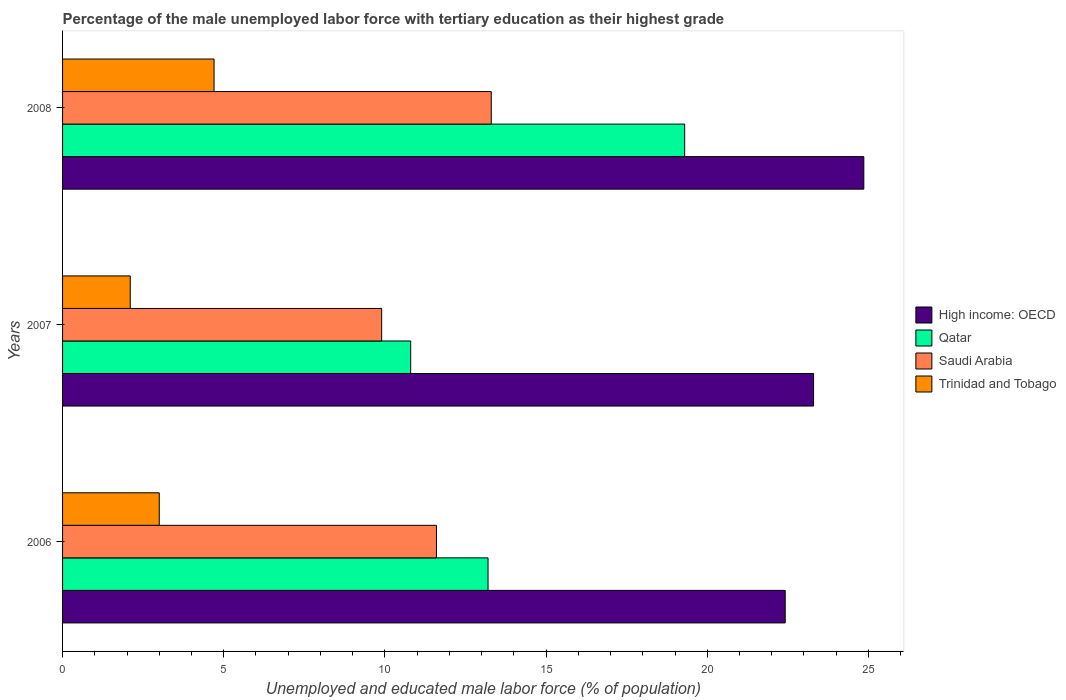How many different coloured bars are there?
Ensure brevity in your answer.  4. Are the number of bars on each tick of the Y-axis equal?
Give a very brief answer. Yes. What is the label of the 2nd group of bars from the top?
Give a very brief answer. 2007. What is the percentage of the unemployed male labor force with tertiary education in Qatar in 2006?
Make the answer very short. 13.2. Across all years, what is the maximum percentage of the unemployed male labor force with tertiary education in High income: OECD?
Provide a succinct answer. 24.86. Across all years, what is the minimum percentage of the unemployed male labor force with tertiary education in High income: OECD?
Provide a succinct answer. 22.42. In which year was the percentage of the unemployed male labor force with tertiary education in Trinidad and Tobago minimum?
Offer a terse response. 2007. What is the total percentage of the unemployed male labor force with tertiary education in High income: OECD in the graph?
Your answer should be very brief. 70.58. What is the difference between the percentage of the unemployed male labor force with tertiary education in High income: OECD in 2006 and that in 2007?
Your response must be concise. -0.88. What is the difference between the percentage of the unemployed male labor force with tertiary education in Qatar in 2008 and the percentage of the unemployed male labor force with tertiary education in Trinidad and Tobago in 2007?
Keep it short and to the point. 17.2. What is the average percentage of the unemployed male labor force with tertiary education in High income: OECD per year?
Your answer should be very brief. 23.53. In the year 2006, what is the difference between the percentage of the unemployed male labor force with tertiary education in High income: OECD and percentage of the unemployed male labor force with tertiary education in Qatar?
Make the answer very short. 9.22. What is the ratio of the percentage of the unemployed male labor force with tertiary education in Qatar in 2007 to that in 2008?
Your answer should be very brief. 0.56. Is the difference between the percentage of the unemployed male labor force with tertiary education in High income: OECD in 2006 and 2007 greater than the difference between the percentage of the unemployed male labor force with tertiary education in Qatar in 2006 and 2007?
Provide a succinct answer. No. What is the difference between the highest and the second highest percentage of the unemployed male labor force with tertiary education in Qatar?
Keep it short and to the point. 6.1. What is the difference between the highest and the lowest percentage of the unemployed male labor force with tertiary education in Qatar?
Your answer should be very brief. 8.5. In how many years, is the percentage of the unemployed male labor force with tertiary education in High income: OECD greater than the average percentage of the unemployed male labor force with tertiary education in High income: OECD taken over all years?
Your answer should be compact. 1. What does the 1st bar from the top in 2006 represents?
Make the answer very short. Trinidad and Tobago. What does the 3rd bar from the bottom in 2008 represents?
Make the answer very short. Saudi Arabia. Are the values on the major ticks of X-axis written in scientific E-notation?
Provide a short and direct response. No. Does the graph contain grids?
Keep it short and to the point. No. What is the title of the graph?
Offer a very short reply. Percentage of the male unemployed labor force with tertiary education as their highest grade. Does "Gambia, The" appear as one of the legend labels in the graph?
Your answer should be very brief. No. What is the label or title of the X-axis?
Your response must be concise. Unemployed and educated male labor force (% of population). What is the label or title of the Y-axis?
Make the answer very short. Years. What is the Unemployed and educated male labor force (% of population) in High income: OECD in 2006?
Your answer should be very brief. 22.42. What is the Unemployed and educated male labor force (% of population) of Qatar in 2006?
Your answer should be compact. 13.2. What is the Unemployed and educated male labor force (% of population) of Saudi Arabia in 2006?
Your answer should be very brief. 11.6. What is the Unemployed and educated male labor force (% of population) of High income: OECD in 2007?
Provide a succinct answer. 23.3. What is the Unemployed and educated male labor force (% of population) in Qatar in 2007?
Make the answer very short. 10.8. What is the Unemployed and educated male labor force (% of population) of Saudi Arabia in 2007?
Provide a succinct answer. 9.9. What is the Unemployed and educated male labor force (% of population) in Trinidad and Tobago in 2007?
Your answer should be very brief. 2.1. What is the Unemployed and educated male labor force (% of population) of High income: OECD in 2008?
Ensure brevity in your answer.  24.86. What is the Unemployed and educated male labor force (% of population) in Qatar in 2008?
Your answer should be very brief. 19.3. What is the Unemployed and educated male labor force (% of population) in Saudi Arabia in 2008?
Provide a succinct answer. 13.3. What is the Unemployed and educated male labor force (% of population) of Trinidad and Tobago in 2008?
Your answer should be very brief. 4.7. Across all years, what is the maximum Unemployed and educated male labor force (% of population) in High income: OECD?
Provide a short and direct response. 24.86. Across all years, what is the maximum Unemployed and educated male labor force (% of population) in Qatar?
Your response must be concise. 19.3. Across all years, what is the maximum Unemployed and educated male labor force (% of population) of Saudi Arabia?
Give a very brief answer. 13.3. Across all years, what is the maximum Unemployed and educated male labor force (% of population) of Trinidad and Tobago?
Provide a short and direct response. 4.7. Across all years, what is the minimum Unemployed and educated male labor force (% of population) of High income: OECD?
Give a very brief answer. 22.42. Across all years, what is the minimum Unemployed and educated male labor force (% of population) of Qatar?
Give a very brief answer. 10.8. Across all years, what is the minimum Unemployed and educated male labor force (% of population) in Saudi Arabia?
Ensure brevity in your answer.  9.9. Across all years, what is the minimum Unemployed and educated male labor force (% of population) in Trinidad and Tobago?
Your answer should be compact. 2.1. What is the total Unemployed and educated male labor force (% of population) in High income: OECD in the graph?
Your answer should be very brief. 70.58. What is the total Unemployed and educated male labor force (% of population) in Qatar in the graph?
Give a very brief answer. 43.3. What is the total Unemployed and educated male labor force (% of population) of Saudi Arabia in the graph?
Keep it short and to the point. 34.8. What is the total Unemployed and educated male labor force (% of population) of Trinidad and Tobago in the graph?
Your answer should be very brief. 9.8. What is the difference between the Unemployed and educated male labor force (% of population) in High income: OECD in 2006 and that in 2007?
Make the answer very short. -0.88. What is the difference between the Unemployed and educated male labor force (% of population) in Trinidad and Tobago in 2006 and that in 2007?
Ensure brevity in your answer.  0.9. What is the difference between the Unemployed and educated male labor force (% of population) in High income: OECD in 2006 and that in 2008?
Offer a terse response. -2.44. What is the difference between the Unemployed and educated male labor force (% of population) of Qatar in 2006 and that in 2008?
Keep it short and to the point. -6.1. What is the difference between the Unemployed and educated male labor force (% of population) of Saudi Arabia in 2006 and that in 2008?
Ensure brevity in your answer.  -1.7. What is the difference between the Unemployed and educated male labor force (% of population) in High income: OECD in 2007 and that in 2008?
Keep it short and to the point. -1.56. What is the difference between the Unemployed and educated male labor force (% of population) in Saudi Arabia in 2007 and that in 2008?
Provide a short and direct response. -3.4. What is the difference between the Unemployed and educated male labor force (% of population) of Trinidad and Tobago in 2007 and that in 2008?
Offer a very short reply. -2.6. What is the difference between the Unemployed and educated male labor force (% of population) in High income: OECD in 2006 and the Unemployed and educated male labor force (% of population) in Qatar in 2007?
Give a very brief answer. 11.62. What is the difference between the Unemployed and educated male labor force (% of population) of High income: OECD in 2006 and the Unemployed and educated male labor force (% of population) of Saudi Arabia in 2007?
Your response must be concise. 12.52. What is the difference between the Unemployed and educated male labor force (% of population) of High income: OECD in 2006 and the Unemployed and educated male labor force (% of population) of Trinidad and Tobago in 2007?
Your answer should be compact. 20.32. What is the difference between the Unemployed and educated male labor force (% of population) of Qatar in 2006 and the Unemployed and educated male labor force (% of population) of Saudi Arabia in 2007?
Offer a very short reply. 3.3. What is the difference between the Unemployed and educated male labor force (% of population) of Qatar in 2006 and the Unemployed and educated male labor force (% of population) of Trinidad and Tobago in 2007?
Give a very brief answer. 11.1. What is the difference between the Unemployed and educated male labor force (% of population) of High income: OECD in 2006 and the Unemployed and educated male labor force (% of population) of Qatar in 2008?
Make the answer very short. 3.12. What is the difference between the Unemployed and educated male labor force (% of population) of High income: OECD in 2006 and the Unemployed and educated male labor force (% of population) of Saudi Arabia in 2008?
Your answer should be very brief. 9.12. What is the difference between the Unemployed and educated male labor force (% of population) in High income: OECD in 2006 and the Unemployed and educated male labor force (% of population) in Trinidad and Tobago in 2008?
Keep it short and to the point. 17.72. What is the difference between the Unemployed and educated male labor force (% of population) in Qatar in 2006 and the Unemployed and educated male labor force (% of population) in Saudi Arabia in 2008?
Provide a short and direct response. -0.1. What is the difference between the Unemployed and educated male labor force (% of population) in High income: OECD in 2007 and the Unemployed and educated male labor force (% of population) in Qatar in 2008?
Your response must be concise. 4. What is the difference between the Unemployed and educated male labor force (% of population) in High income: OECD in 2007 and the Unemployed and educated male labor force (% of population) in Saudi Arabia in 2008?
Your answer should be very brief. 10. What is the difference between the Unemployed and educated male labor force (% of population) of High income: OECD in 2007 and the Unemployed and educated male labor force (% of population) of Trinidad and Tobago in 2008?
Your answer should be very brief. 18.6. What is the average Unemployed and educated male labor force (% of population) in High income: OECD per year?
Offer a terse response. 23.53. What is the average Unemployed and educated male labor force (% of population) of Qatar per year?
Provide a short and direct response. 14.43. What is the average Unemployed and educated male labor force (% of population) in Saudi Arabia per year?
Offer a terse response. 11.6. What is the average Unemployed and educated male labor force (% of population) of Trinidad and Tobago per year?
Your answer should be very brief. 3.27. In the year 2006, what is the difference between the Unemployed and educated male labor force (% of population) of High income: OECD and Unemployed and educated male labor force (% of population) of Qatar?
Provide a succinct answer. 9.22. In the year 2006, what is the difference between the Unemployed and educated male labor force (% of population) of High income: OECD and Unemployed and educated male labor force (% of population) of Saudi Arabia?
Your response must be concise. 10.82. In the year 2006, what is the difference between the Unemployed and educated male labor force (% of population) in High income: OECD and Unemployed and educated male labor force (% of population) in Trinidad and Tobago?
Offer a terse response. 19.42. In the year 2006, what is the difference between the Unemployed and educated male labor force (% of population) of Qatar and Unemployed and educated male labor force (% of population) of Saudi Arabia?
Provide a succinct answer. 1.6. In the year 2006, what is the difference between the Unemployed and educated male labor force (% of population) of Saudi Arabia and Unemployed and educated male labor force (% of population) of Trinidad and Tobago?
Make the answer very short. 8.6. In the year 2007, what is the difference between the Unemployed and educated male labor force (% of population) of High income: OECD and Unemployed and educated male labor force (% of population) of Qatar?
Provide a short and direct response. 12.5. In the year 2007, what is the difference between the Unemployed and educated male labor force (% of population) in High income: OECD and Unemployed and educated male labor force (% of population) in Saudi Arabia?
Offer a very short reply. 13.4. In the year 2007, what is the difference between the Unemployed and educated male labor force (% of population) in High income: OECD and Unemployed and educated male labor force (% of population) in Trinidad and Tobago?
Your answer should be very brief. 21.2. In the year 2007, what is the difference between the Unemployed and educated male labor force (% of population) in Qatar and Unemployed and educated male labor force (% of population) in Saudi Arabia?
Keep it short and to the point. 0.9. In the year 2007, what is the difference between the Unemployed and educated male labor force (% of population) of Saudi Arabia and Unemployed and educated male labor force (% of population) of Trinidad and Tobago?
Offer a very short reply. 7.8. In the year 2008, what is the difference between the Unemployed and educated male labor force (% of population) in High income: OECD and Unemployed and educated male labor force (% of population) in Qatar?
Provide a short and direct response. 5.56. In the year 2008, what is the difference between the Unemployed and educated male labor force (% of population) in High income: OECD and Unemployed and educated male labor force (% of population) in Saudi Arabia?
Make the answer very short. 11.56. In the year 2008, what is the difference between the Unemployed and educated male labor force (% of population) in High income: OECD and Unemployed and educated male labor force (% of population) in Trinidad and Tobago?
Your response must be concise. 20.16. In the year 2008, what is the difference between the Unemployed and educated male labor force (% of population) of Qatar and Unemployed and educated male labor force (% of population) of Saudi Arabia?
Make the answer very short. 6. What is the ratio of the Unemployed and educated male labor force (% of population) of High income: OECD in 2006 to that in 2007?
Offer a terse response. 0.96. What is the ratio of the Unemployed and educated male labor force (% of population) of Qatar in 2006 to that in 2007?
Offer a terse response. 1.22. What is the ratio of the Unemployed and educated male labor force (% of population) of Saudi Arabia in 2006 to that in 2007?
Keep it short and to the point. 1.17. What is the ratio of the Unemployed and educated male labor force (% of population) in Trinidad and Tobago in 2006 to that in 2007?
Make the answer very short. 1.43. What is the ratio of the Unemployed and educated male labor force (% of population) in High income: OECD in 2006 to that in 2008?
Give a very brief answer. 0.9. What is the ratio of the Unemployed and educated male labor force (% of population) in Qatar in 2006 to that in 2008?
Provide a short and direct response. 0.68. What is the ratio of the Unemployed and educated male labor force (% of population) of Saudi Arabia in 2006 to that in 2008?
Provide a succinct answer. 0.87. What is the ratio of the Unemployed and educated male labor force (% of population) in Trinidad and Tobago in 2006 to that in 2008?
Ensure brevity in your answer.  0.64. What is the ratio of the Unemployed and educated male labor force (% of population) in High income: OECD in 2007 to that in 2008?
Your response must be concise. 0.94. What is the ratio of the Unemployed and educated male labor force (% of population) of Qatar in 2007 to that in 2008?
Offer a terse response. 0.56. What is the ratio of the Unemployed and educated male labor force (% of population) of Saudi Arabia in 2007 to that in 2008?
Your answer should be very brief. 0.74. What is the ratio of the Unemployed and educated male labor force (% of population) in Trinidad and Tobago in 2007 to that in 2008?
Provide a succinct answer. 0.45. What is the difference between the highest and the second highest Unemployed and educated male labor force (% of population) of High income: OECD?
Offer a terse response. 1.56. What is the difference between the highest and the lowest Unemployed and educated male labor force (% of population) in High income: OECD?
Your answer should be compact. 2.44. What is the difference between the highest and the lowest Unemployed and educated male labor force (% of population) in Qatar?
Provide a short and direct response. 8.5. What is the difference between the highest and the lowest Unemployed and educated male labor force (% of population) in Saudi Arabia?
Provide a succinct answer. 3.4. What is the difference between the highest and the lowest Unemployed and educated male labor force (% of population) in Trinidad and Tobago?
Your answer should be very brief. 2.6. 